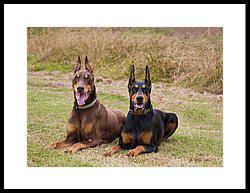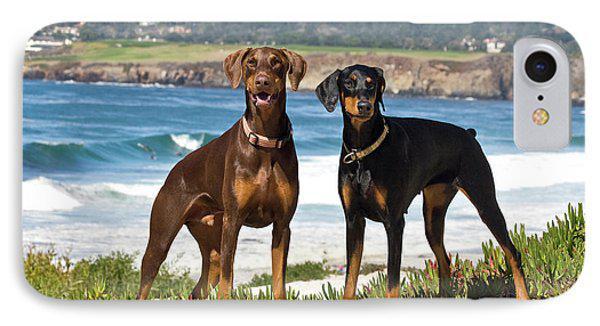The first image is the image on the left, the second image is the image on the right. For the images shown, is this caption "Each image contains multiple dobermans, at least one image shows dobermans in front of water, and one image shows exactly two pointy-eared dobermans side-by-side." true? Answer yes or no. Yes. The first image is the image on the left, the second image is the image on the right. For the images displayed, is the sentence "The left image contains two dogs." factually correct? Answer yes or no. Yes. 